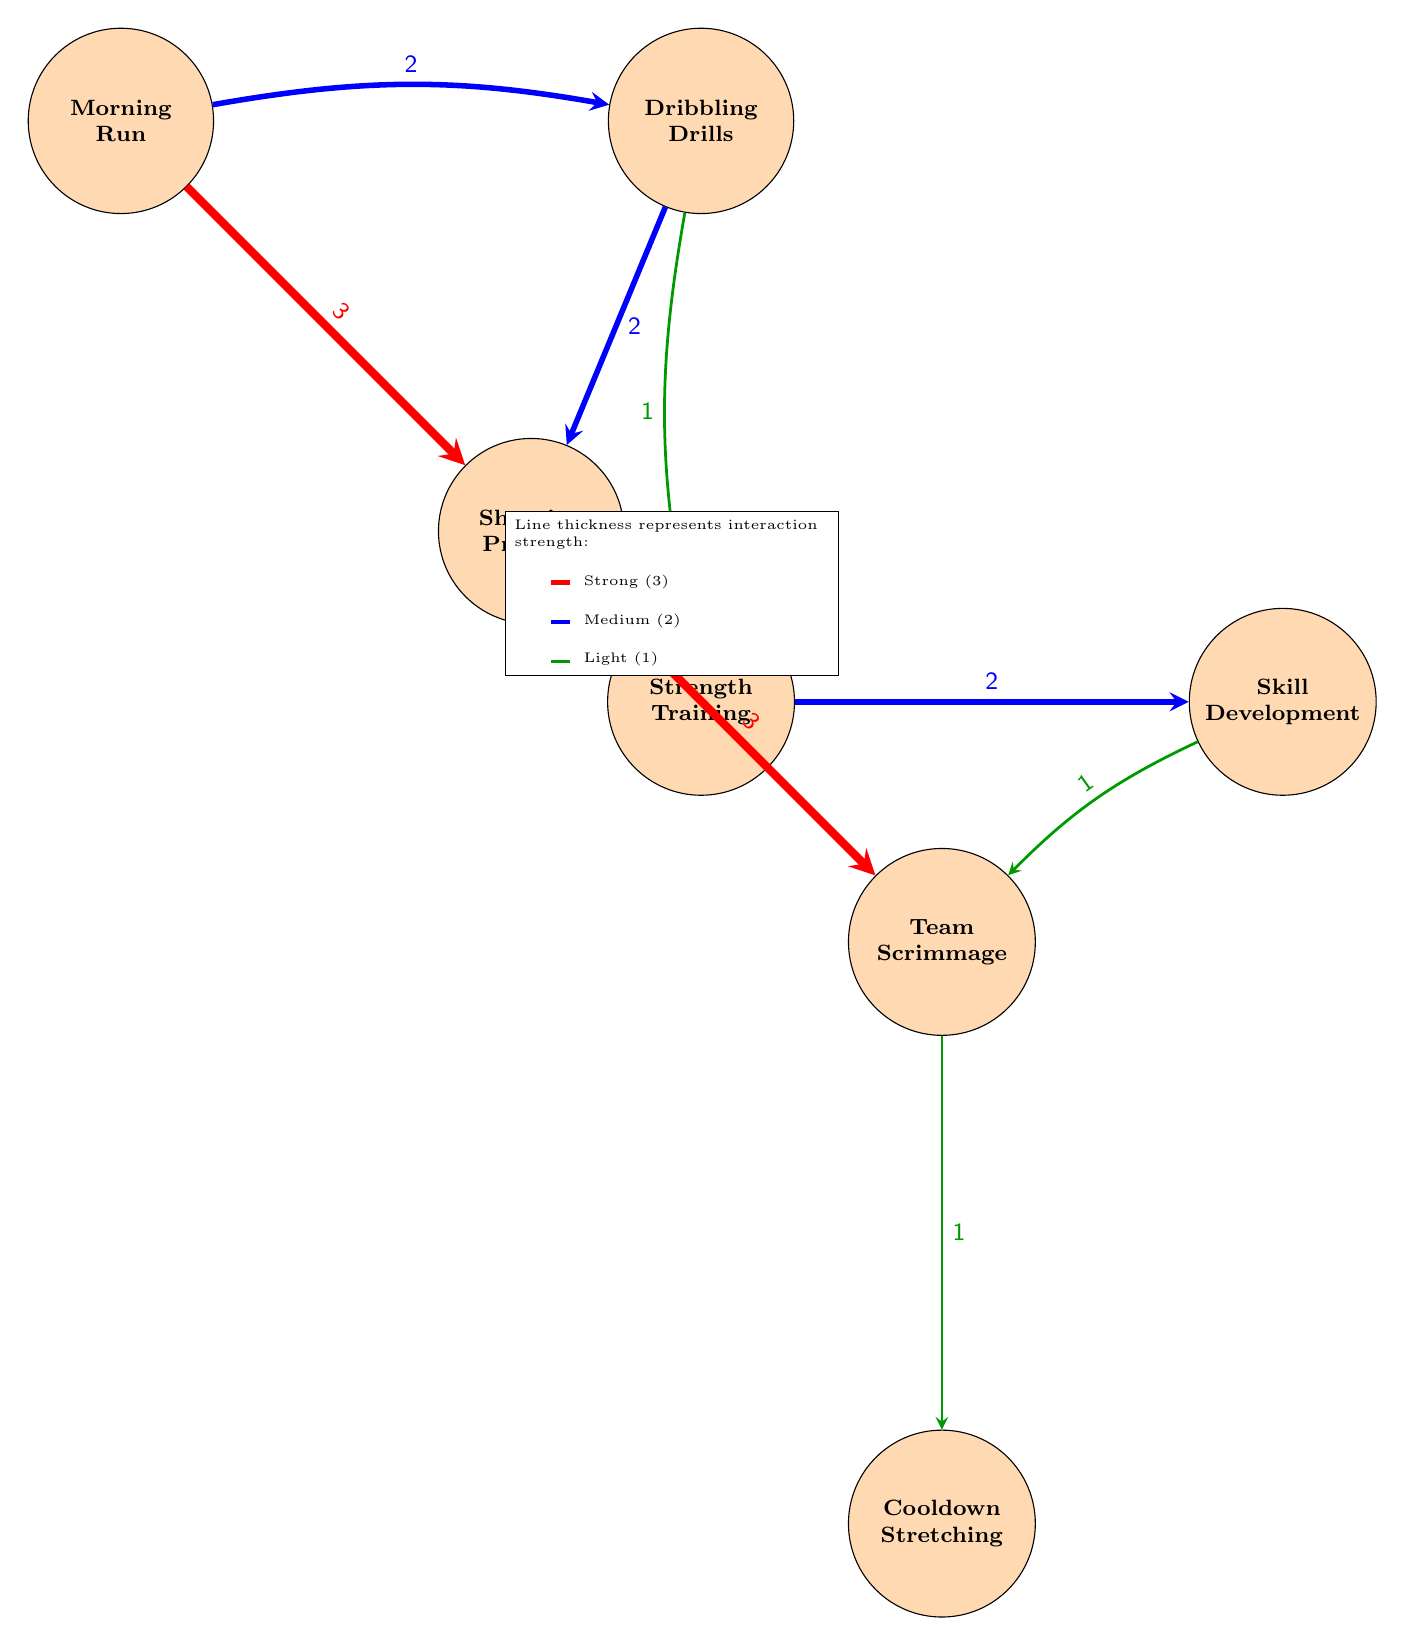What activities are directly linked to Morning Run? From the diagram, I can see that "Morning Run" is linked to two activities: "Dribbling Drills" and "Shooting Practice". The links can be traced directly from the node "Morning Run" to these two other nodes.
Answer: Dribbling Drills, Shooting Practice How many activities have a medium interaction strength of 2? Looking through the diagram, I will count the connections that represent a medium strength (indicated by blue lines). The connections are: Morning Run to Dribbling Drills, Morning Run to Shooting Practice, Dribbling Drills to Shooting Practice, Strength Training to Skill Development. Therefore, there are four interactions with a medium strength of 2.
Answer: 4 What is the strongest interaction in the diagram? The strongest interaction can be found by identifying the thickest connecting lines in the diagram, which represent a strength of 3. There are two occurrences: one from "Morning Run" to "Shooting Practice" and the other from "Shooting Practice" to "Team Scrimmage".
Answer: Morning Run to Shooting Practice, Shooting Practice to Team Scrimmage Which activity is connected to Cooldown Stretching? I examine the diagram for outgoing links from the node "Cooldown Stretching". It is linked back to the "Team Scrimmage", which is the only activity connected to it.
Answer: Team Scrimmage What two activities are connected with a light interaction strength of 1? Looking for connections represented by the thinnest lines (green), I see three interactions with a strength of 1: "Dribbling Drills" to "Strength Training", "Skill Development" to "Team Scrimmage", and "Team Scrimmage" to "Cooldown Stretching." However, the question specifies two activities; therefore, one instance can be taken from any of them.
Answer: Dribbling Drills to Strength Training 